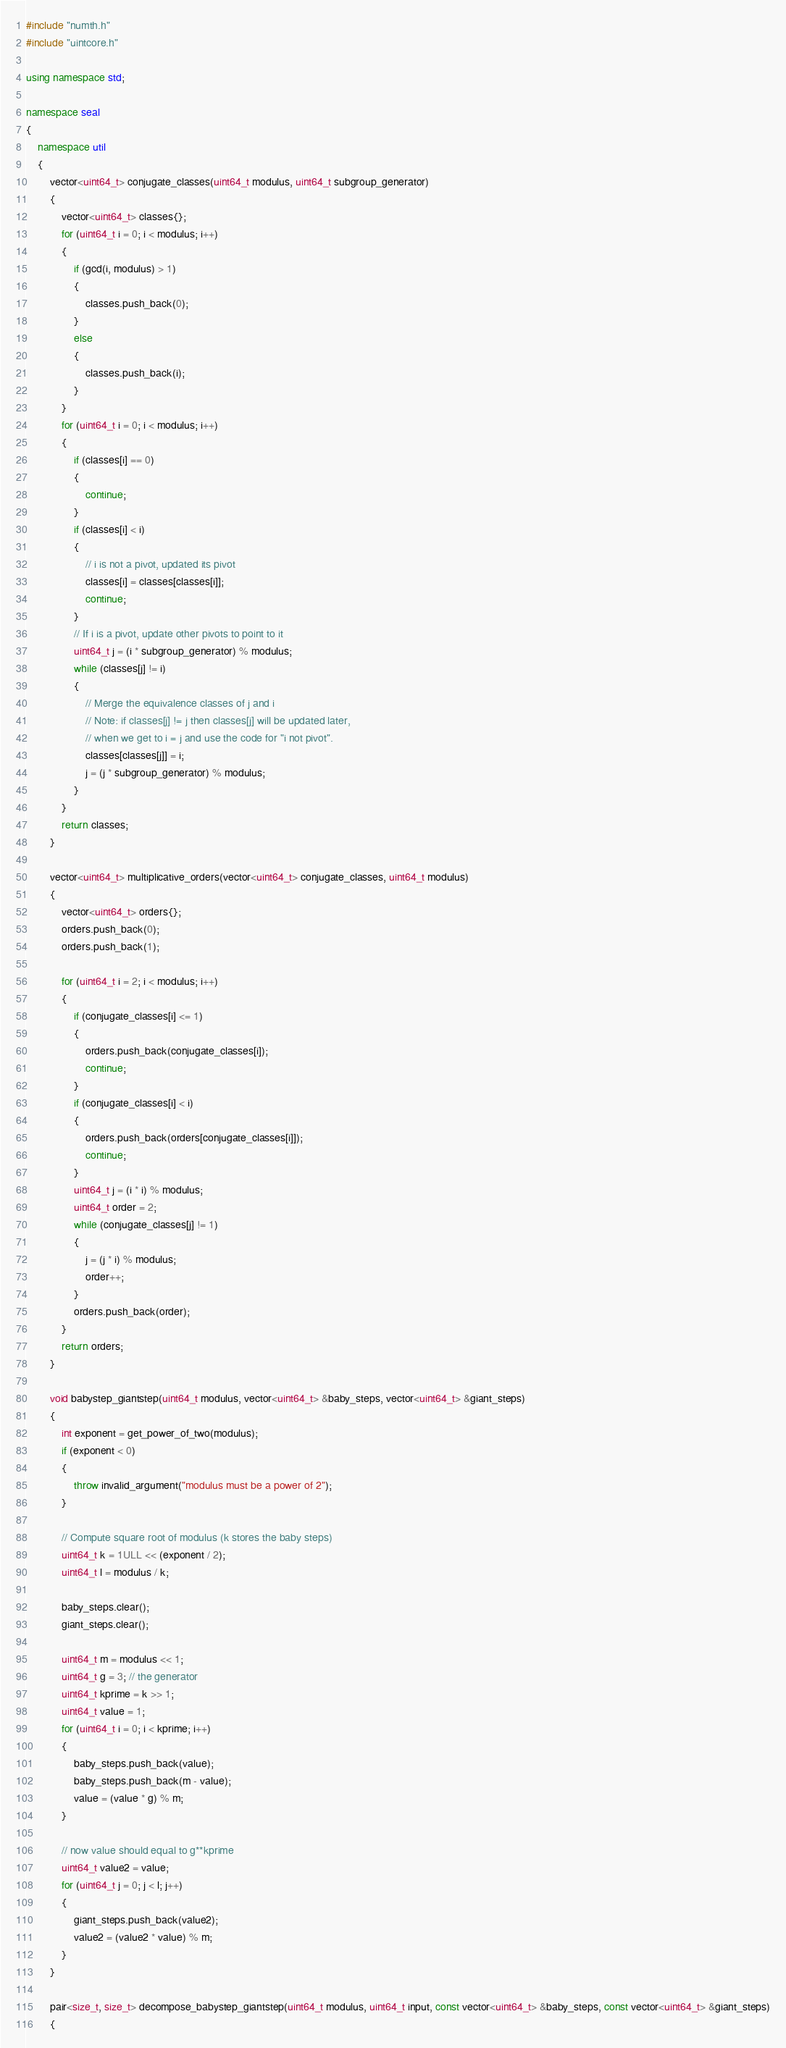Convert code to text. <code><loc_0><loc_0><loc_500><loc_500><_C++_>#include "numth.h"
#include "uintcore.h"

using namespace std;

namespace seal
{
    namespace util
    {
        vector<uint64_t> conjugate_classes(uint64_t modulus, uint64_t subgroup_generator)
        {
            vector<uint64_t> classes{};
            for (uint64_t i = 0; i < modulus; i++)
            {
                if (gcd(i, modulus) > 1)
                {
                    classes.push_back(0);
                }
                else
                {
                    classes.push_back(i);
                }
            }
            for (uint64_t i = 0; i < modulus; i++)
            {
                if (classes[i] == 0)
                {
                    continue;
                }
                if (classes[i] < i)
                {
                    // i is not a pivot, updated its pivot
                    classes[i] = classes[classes[i]];
                    continue;
                }
                // If i is a pivot, update other pivots to point to it
                uint64_t j = (i * subgroup_generator) % modulus;
                while (classes[j] != i)
                {
                    // Merge the equivalence classes of j and i
                    // Note: if classes[j] != j then classes[j] will be updated later,
                    // when we get to i = j and use the code for "i not pivot".
                    classes[classes[j]] = i;
                    j = (j * subgroup_generator) % modulus;
                }
            }
            return classes;
        }

        vector<uint64_t> multiplicative_orders(vector<uint64_t> conjugate_classes, uint64_t modulus)
        {
            vector<uint64_t> orders{};
            orders.push_back(0);
            orders.push_back(1);

            for (uint64_t i = 2; i < modulus; i++)
            {
                if (conjugate_classes[i] <= 1)
                {
                    orders.push_back(conjugate_classes[i]);
                    continue;
                }
                if (conjugate_classes[i] < i)
                {
                    orders.push_back(orders[conjugate_classes[i]]);
                    continue;
                }
                uint64_t j = (i * i) % modulus;
                uint64_t order = 2;
                while (conjugate_classes[j] != 1)
                {
                    j = (j * i) % modulus;
                    order++;
                }
                orders.push_back(order);
            }
            return orders;
        }

        void babystep_giantstep(uint64_t modulus, vector<uint64_t> &baby_steps, vector<uint64_t> &giant_steps)
        {
            int exponent = get_power_of_two(modulus);
            if (exponent < 0)
            {
                throw invalid_argument("modulus must be a power of 2");
            }

            // Compute square root of modulus (k stores the baby steps)
            uint64_t k = 1ULL << (exponent / 2);
            uint64_t l = modulus / k;

            baby_steps.clear();
            giant_steps.clear();

            uint64_t m = modulus << 1;
            uint64_t g = 3; // the generator
            uint64_t kprime = k >> 1;
            uint64_t value = 1;
            for (uint64_t i = 0; i < kprime; i++)
            {
                baby_steps.push_back(value);
                baby_steps.push_back(m - value);
                value = (value * g) % m;
            }

            // now value should equal to g**kprime 
            uint64_t value2 = value;
            for (uint64_t j = 0; j < l; j++)
            {
                giant_steps.push_back(value2);
                value2 = (value2 * value) % m;
            }
        }

        pair<size_t, size_t> decompose_babystep_giantstep(uint64_t modulus, uint64_t input, const vector<uint64_t> &baby_steps, const vector<uint64_t> &giant_steps)
        {</code> 